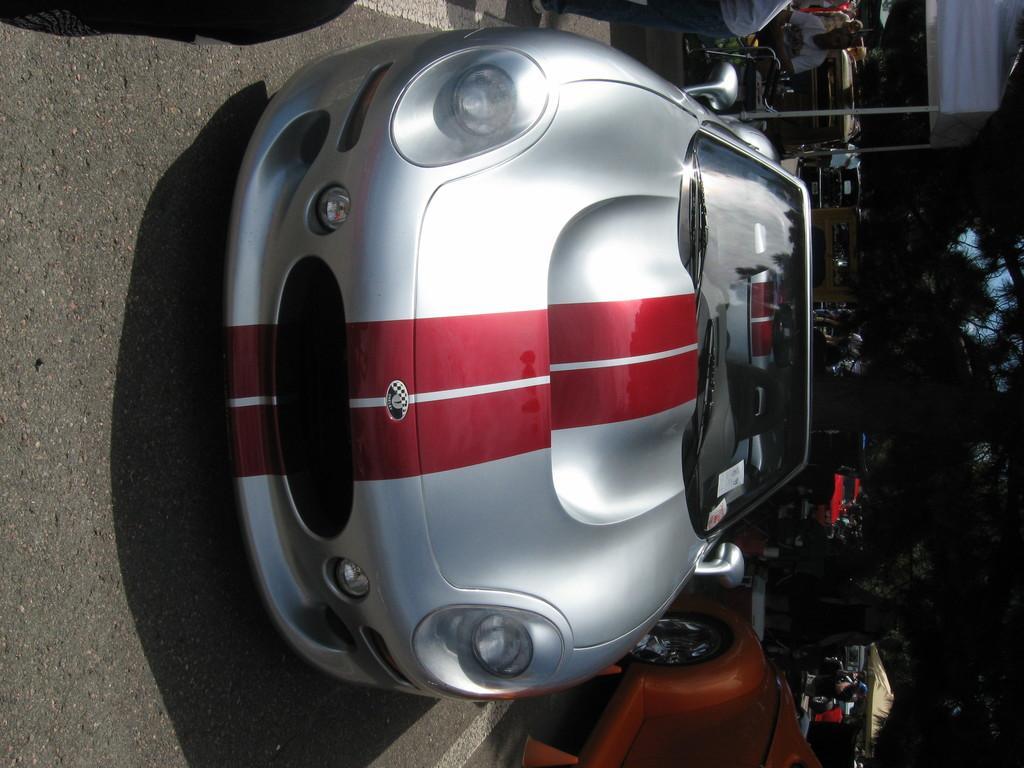Describe this image in one or two sentences. Vehicles are on the road. Background there are tents, trees and people. 